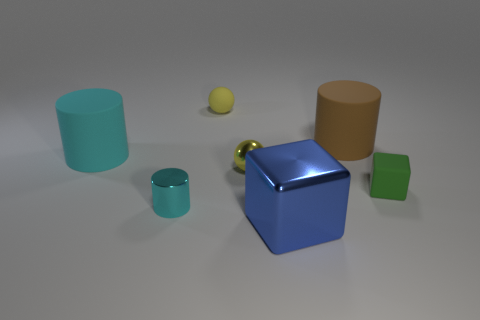Subtract all gray spheres. How many cyan cylinders are left? 2 Subtract all cyan cylinders. How many cylinders are left? 1 Subtract 1 cylinders. How many cylinders are left? 2 Add 2 metal balls. How many objects exist? 9 Subtract all cylinders. How many objects are left? 4 Add 4 yellow objects. How many yellow objects are left? 6 Add 6 rubber cylinders. How many rubber cylinders exist? 8 Subtract 0 purple cubes. How many objects are left? 7 Subtract all big purple shiny balls. Subtract all small green blocks. How many objects are left? 6 